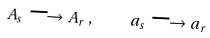Convert formula to latex. <formula><loc_0><loc_0><loc_500><loc_500>A _ { s } \longrightarrow A _ { r } \, , \quad a _ { s } \longrightarrow a _ { r }</formula> 